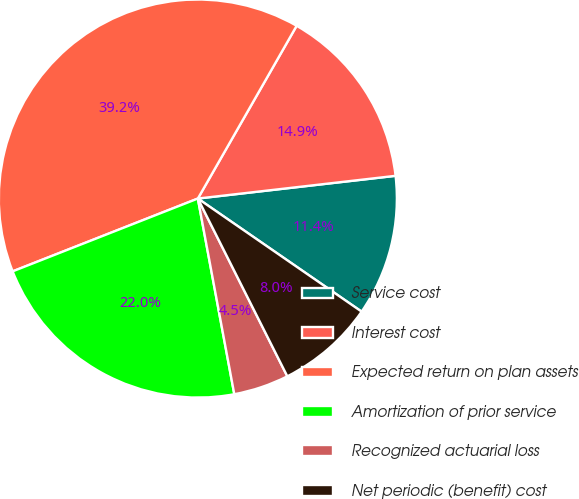<chart> <loc_0><loc_0><loc_500><loc_500><pie_chart><fcel>Service cost<fcel>Interest cost<fcel>Expected return on plan assets<fcel>Amortization of prior service<fcel>Recognized actuarial loss<fcel>Net periodic (benefit) cost<nl><fcel>11.44%<fcel>14.91%<fcel>39.23%<fcel>21.97%<fcel>4.49%<fcel>7.96%<nl></chart> 